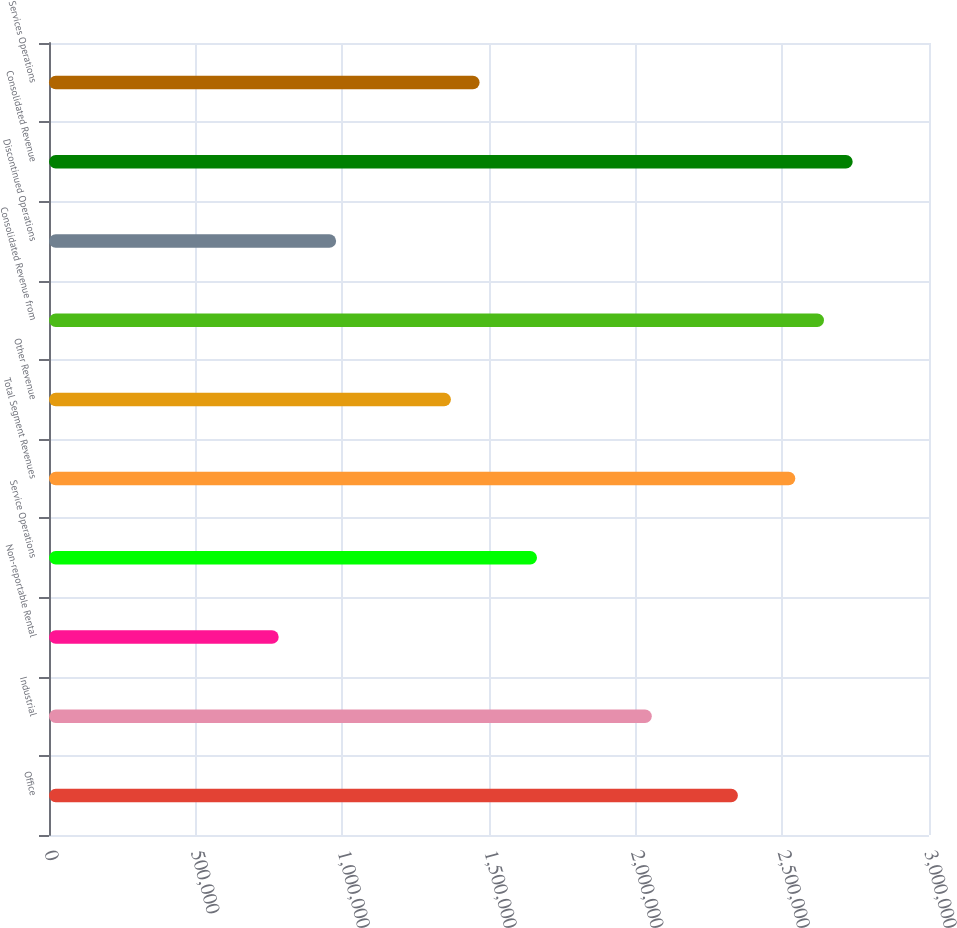Convert chart to OTSL. <chart><loc_0><loc_0><loc_500><loc_500><bar_chart><fcel>Office<fcel>Industrial<fcel>Non-reportable Rental<fcel>Service Operations<fcel>Total Segment Revenues<fcel>Other Revenue<fcel>Consolidated Revenue from<fcel>Discontinued Operations<fcel>Consolidated Revenue<fcel>Services Operations<nl><fcel>2.34852e+06<fcel>2.055e+06<fcel>783115<fcel>1.66365e+06<fcel>2.54419e+06<fcel>1.37014e+06<fcel>2.64203e+06<fcel>978790<fcel>2.73986e+06<fcel>1.46798e+06<nl></chart> 